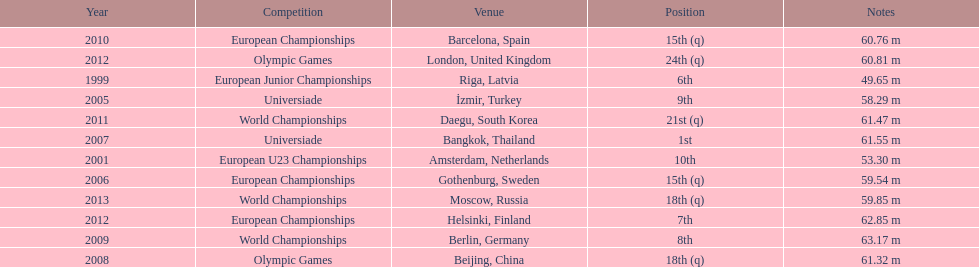What was mayer's best result: i.e his longest throw? 63.17 m. 